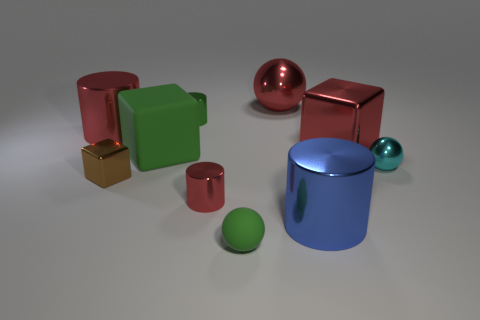Subtract all yellow cylinders. Subtract all purple cubes. How many cylinders are left? 4 Subtract all cubes. How many objects are left? 7 Subtract all purple spheres. Subtract all small brown blocks. How many objects are left? 9 Add 1 metal objects. How many metal objects are left? 9 Add 1 small green things. How many small green things exist? 3 Subtract 1 red blocks. How many objects are left? 9 